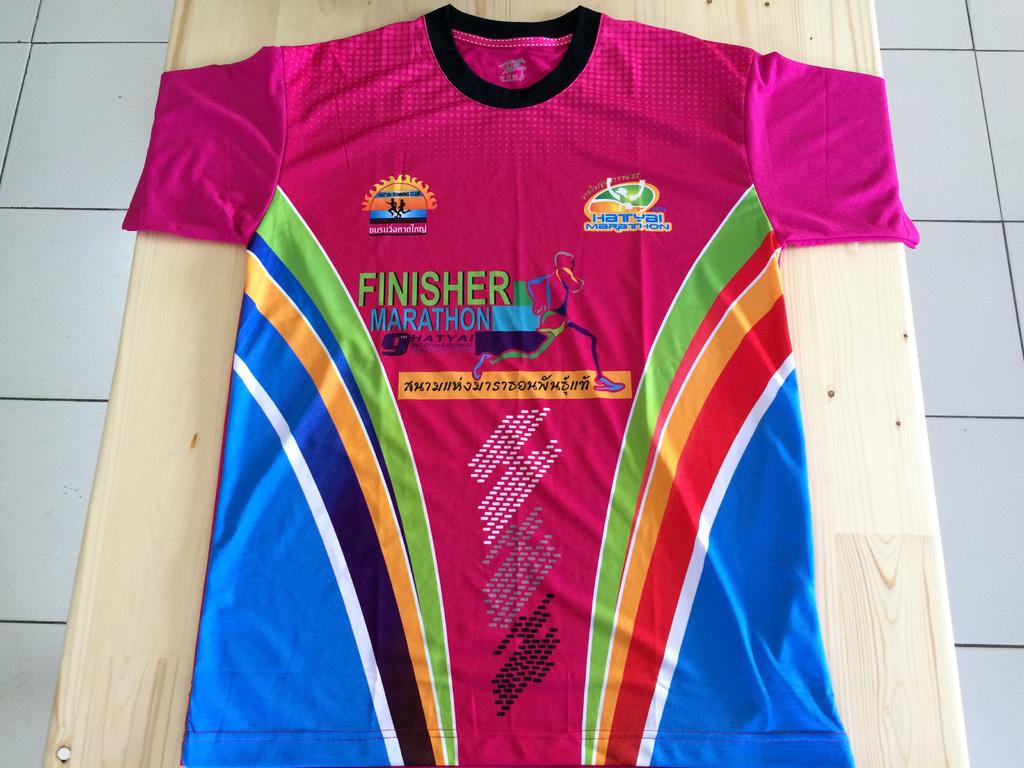What marathon is this?
Your answer should be very brief. Finisher. What number is under the word "marathon"?
Your response must be concise. 9. 